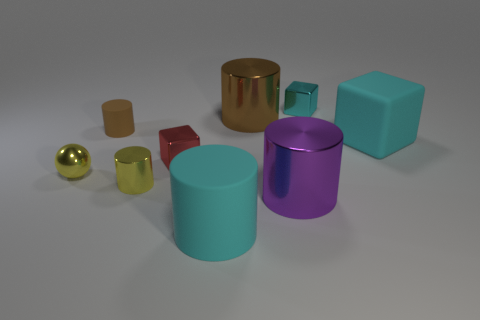Subtract all green cylinders. Subtract all green spheres. How many cylinders are left? 5 Add 1 small red shiny things. How many objects exist? 10 Subtract all cylinders. How many objects are left? 4 Subtract 0 blue cubes. How many objects are left? 9 Subtract all tiny blue metal balls. Subtract all cylinders. How many objects are left? 4 Add 8 large blocks. How many large blocks are left? 9 Add 5 small cyan metal cubes. How many small cyan metal cubes exist? 6 